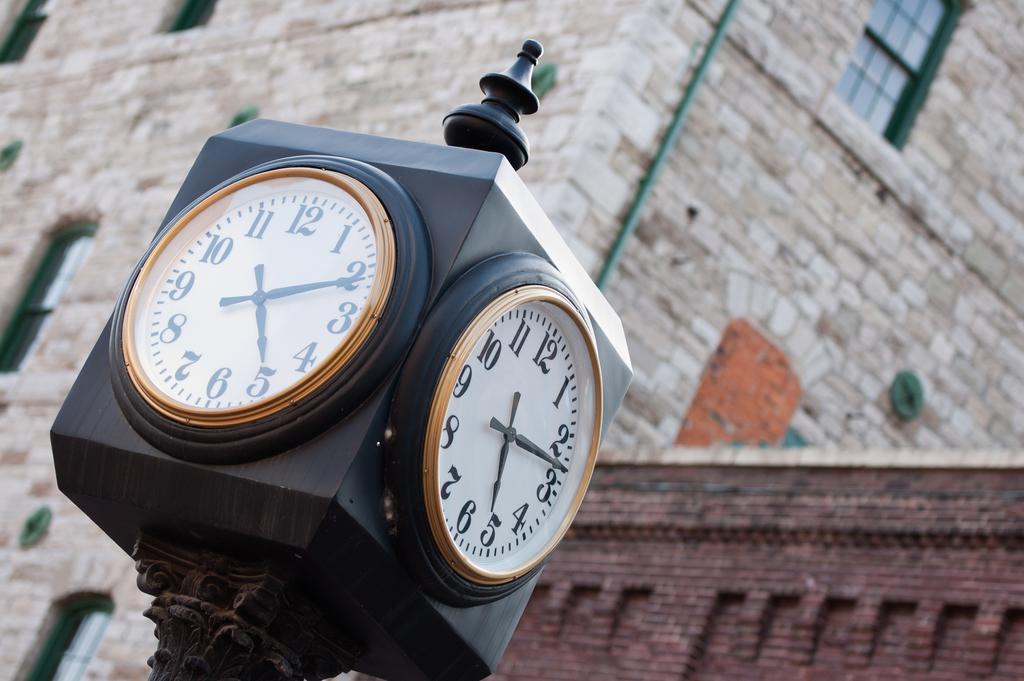What time is shown?
Keep it short and to the point. 5:10. 